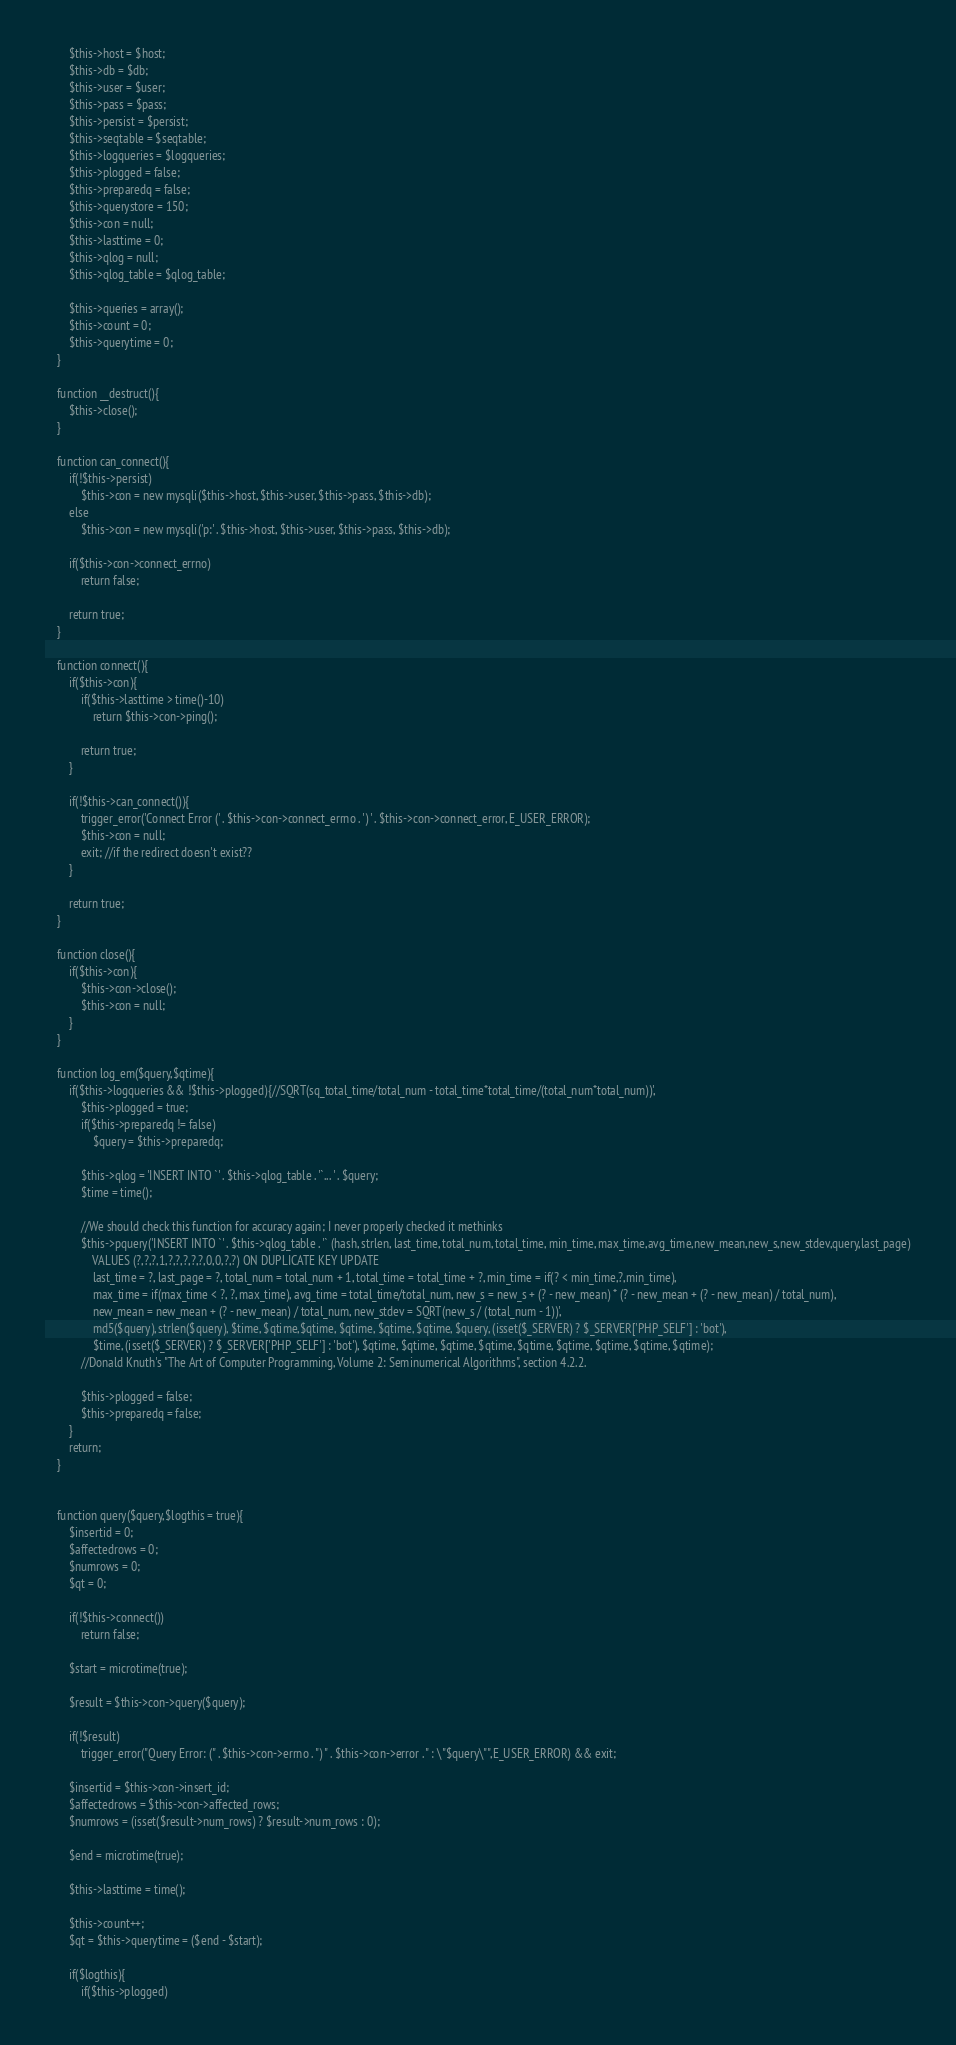<code> <loc_0><loc_0><loc_500><loc_500><_PHP_>
		$this->host = $host;
		$this->db = $db;
		$this->user = $user;
		$this->pass = $pass;
		$this->persist = $persist;
		$this->seqtable = $seqtable;
		$this->logqueries = $logqueries;
		$this->plogged = false;
		$this->preparedq = false;
		$this->querystore = 150;
		$this->con = null;
		$this->lasttime = 0;
		$this->qlog = null;
		$this->qlog_table = $qlog_table;

		$this->queries = array();
		$this->count = 0;
		$this->querytime = 0;
	}

	function __destruct(){
		$this->close();
	}
	
	function can_connect(){
		if(!$this->persist)
			$this->con = new mysqli($this->host, $this->user, $this->pass, $this->db);
		else
			$this->con = new mysqli('p:' . $this->host, $this->user, $this->pass, $this->db);
			
		if($this->con->connect_errno)
			return false;
			
		return true;
	}
	
	function connect(){
		if($this->con){
			if($this->lasttime > time()-10)
				return $this->con->ping();

			return true;
		}
			
		if(!$this->can_connect()){
			trigger_error('Connect Error (' . $this->con->connect_errno . ') ' . $this->con->connect_error, E_USER_ERROR);
			$this->con = null;
			exit; //if the redirect doesn't exist??
		}

		return true;
	}

	function close(){
		if($this->con){
			$this->con->close();
			$this->con = null;
		}
	}
	
	function log_em($query,$qtime){
		if($this->logqueries && !$this->plogged){//SQRT(sq_total_time/total_num - total_time*total_time/(total_num*total_num))',
			$this->plogged = true;
			if($this->preparedq != false)
				$query = $this->preparedq;
			
			$this->qlog = 'INSERT INTO `' . $this->qlog_table . '`... ' . $query;
			$time = time();
			
			//We should check this function for accuracy again; I never properly checked it methinks
			$this->pquery('INSERT INTO `' . $this->qlog_table . '` (hash, strlen, last_time, total_num, total_time, min_time, max_time,avg_time,new_mean,new_s,new_stdev,query,last_page)
				VALUES (?,?,?,1,?,?,?,?,?,0,0,?,?) ON DUPLICATE KEY UPDATE
				last_time = ?, last_page = ?, total_num = total_num + 1, total_time = total_time + ?, min_time = if(? < min_time,?,min_time),
				max_time = if(max_time < ?, ?, max_time), avg_time = total_time/total_num, new_s = new_s + (? - new_mean) * (? - new_mean + (? - new_mean) / total_num),
				new_mean = new_mean + (? - new_mean) / total_num, new_stdev = SQRT(new_s / (total_num - 1))',
				md5($query), strlen($query), $time, $qtime,$qtime, $qtime, $qtime, $qtime, $query, (isset($_SERVER) ? $_SERVER['PHP_SELF'] : 'bot'),
				$time, (isset($_SERVER) ? $_SERVER['PHP_SELF'] : 'bot'), $qtime, $qtime, $qtime, $qtime, $qtime, $qtime, $qtime, $qtime, $qtime);
			//Donald Knuth's "The Art of Computer Programming, Volume 2: Seminumerical Algorithms", section 4.2.2.
			
			$this->plogged = false;
			$this->preparedq = false;
		}
		return;
	}
	
	
	function query($query,$logthis = true){
		$insertid = 0;
		$affectedrows = 0;
		$numrows = 0;
		$qt = 0;
	
		if(!$this->connect())
			return false;

		$start = microtime(true);
		
		$result = $this->con->query($query);
		
		if(!$result)
			trigger_error("Query Error: (" . $this->con->errno . ") " . $this->con->error . " : \"$query\"",E_USER_ERROR) && exit;
		
		$insertid = $this->con->insert_id;
		$affectedrows = $this->con->affected_rows;
		$numrows = (isset($result->num_rows) ? $result->num_rows : 0);

		$end = microtime(true);

		$this->lasttime = time();

		$this->count++;
		$qt = $this->querytime = ($end - $start);
		
		if($logthis){
			if($this->plogged)</code> 